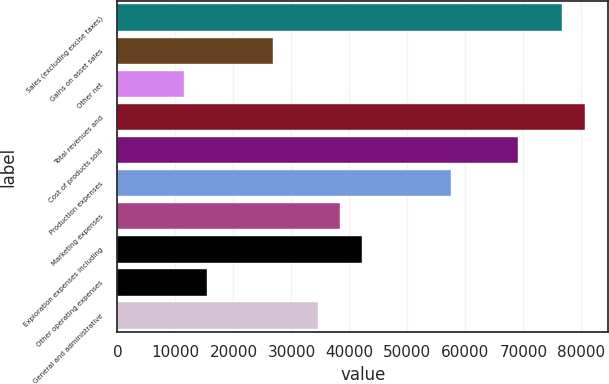<chart> <loc_0><loc_0><loc_500><loc_500><bar_chart><fcel>Sales (excluding excise taxes)<fcel>Gains on asset sales<fcel>Other net<fcel>Total revenues and<fcel>Cost of products sold<fcel>Production expenses<fcel>Marketing expenses<fcel>Exploration expenses including<fcel>Other operating expenses<fcel>General and administrative<nl><fcel>76740.1<fcel>26862.9<fcel>11516.1<fcel>80576.8<fcel>69066.7<fcel>57556.6<fcel>38373<fcel>42209.7<fcel>15352.8<fcel>34536.3<nl></chart> 